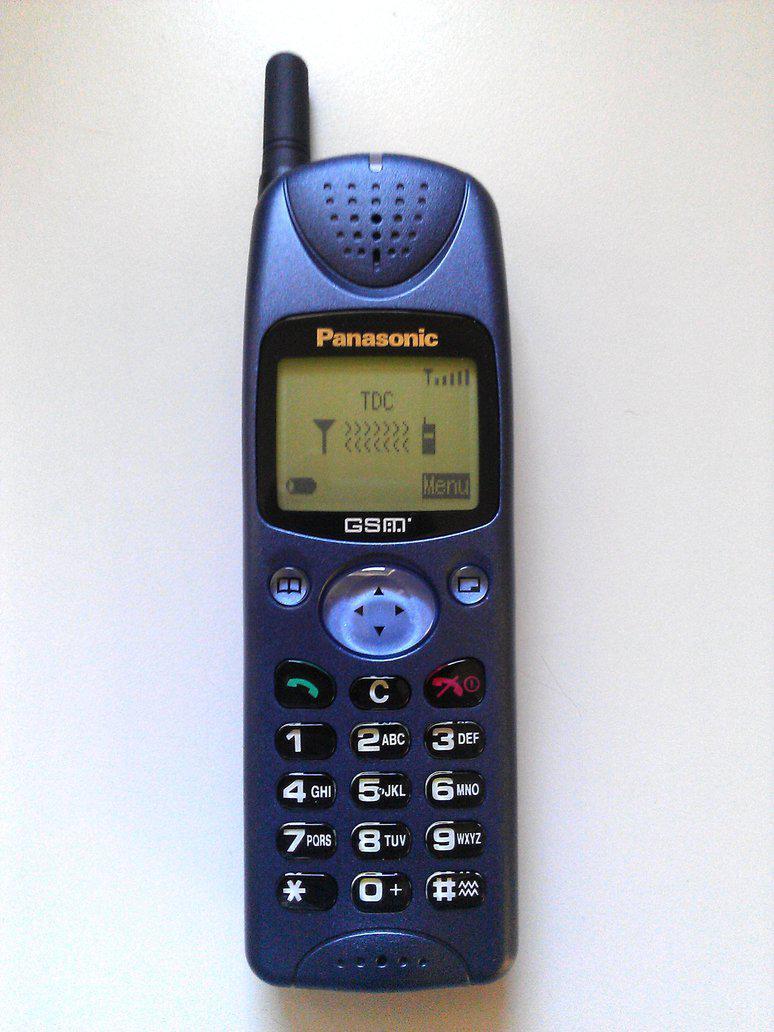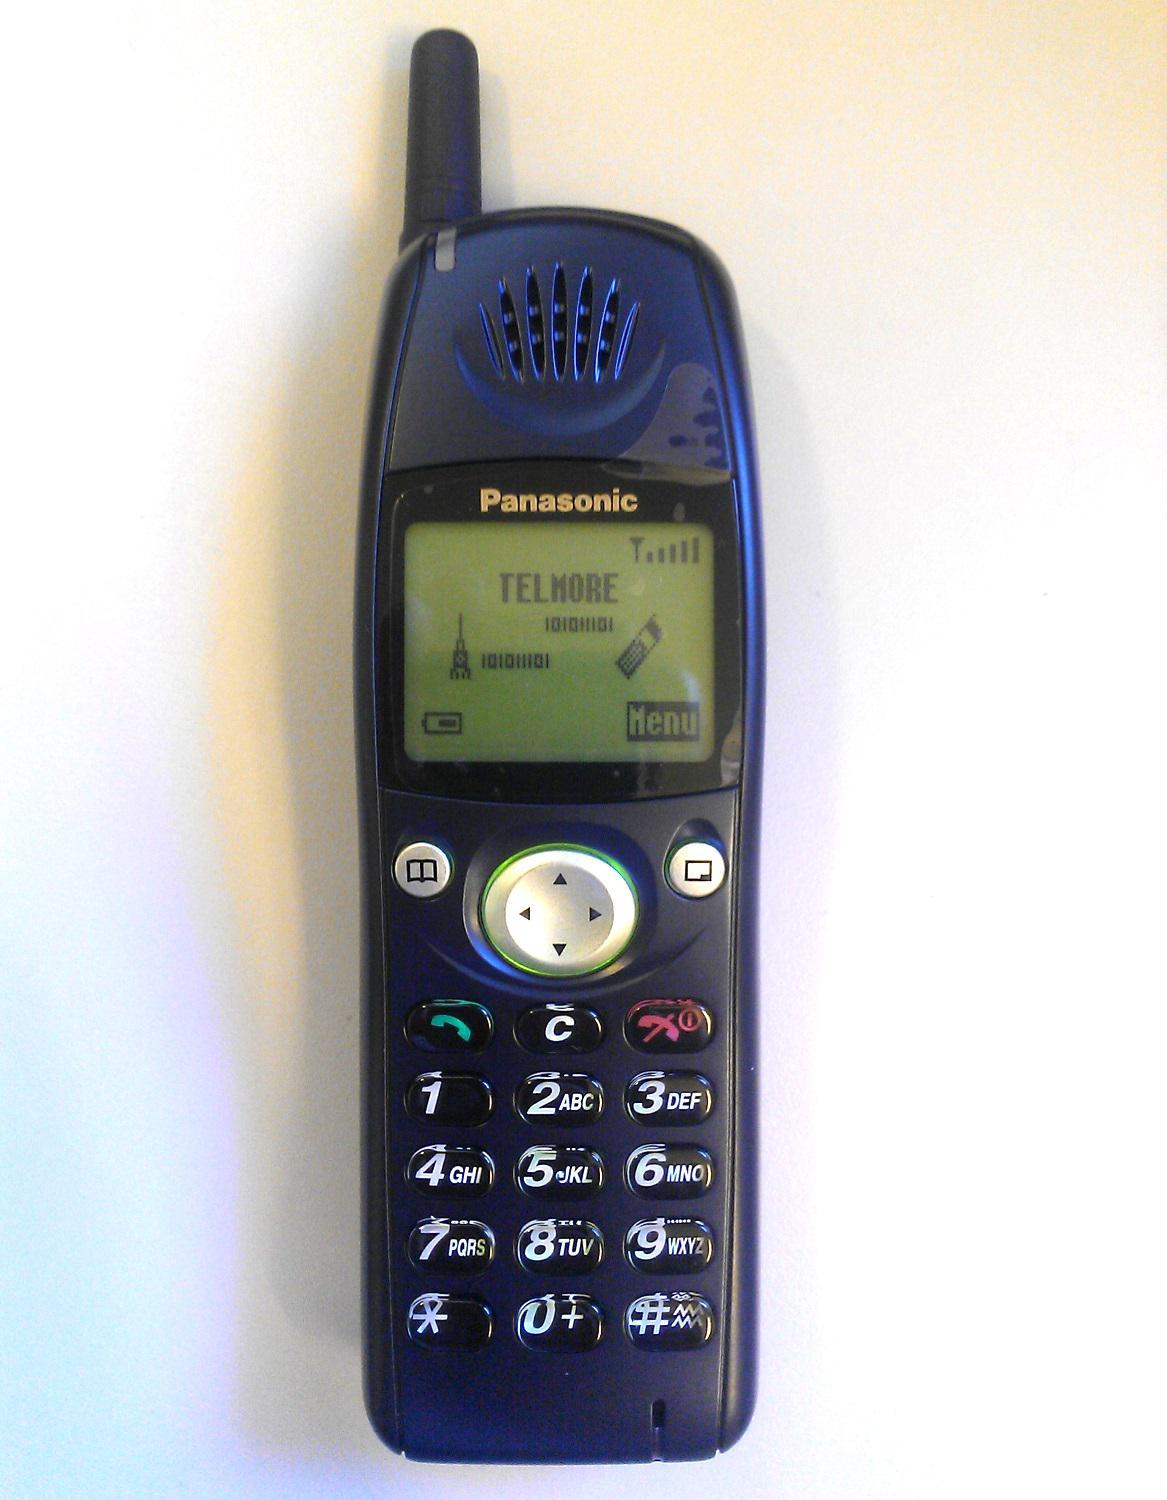The first image is the image on the left, the second image is the image on the right. For the images displayed, is the sentence "Each image contains one narrow rectangular phone displayed vertically, with an antenna projecting from the top left of the phone." factually correct? Answer yes or no. Yes. The first image is the image on the left, the second image is the image on the right. Assess this claim about the two images: "In at least one image the is a single phone with a clear but blue button  in the middle of the phone representing 4 arrow keys.". Correct or not? Answer yes or no. Yes. 